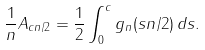Convert formula to latex. <formula><loc_0><loc_0><loc_500><loc_500>\frac { 1 } { n } A _ { c n / 2 } = \frac { 1 } { 2 } \int _ { 0 } ^ { c } g _ { n } ( s n / 2 ) \, d s .</formula> 